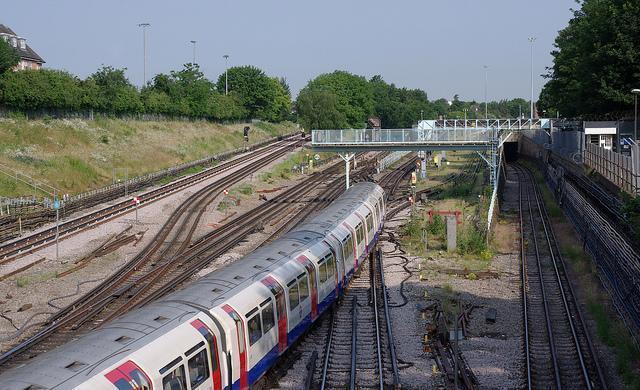How many umbrellas are in the picture?
Give a very brief answer. 0. 